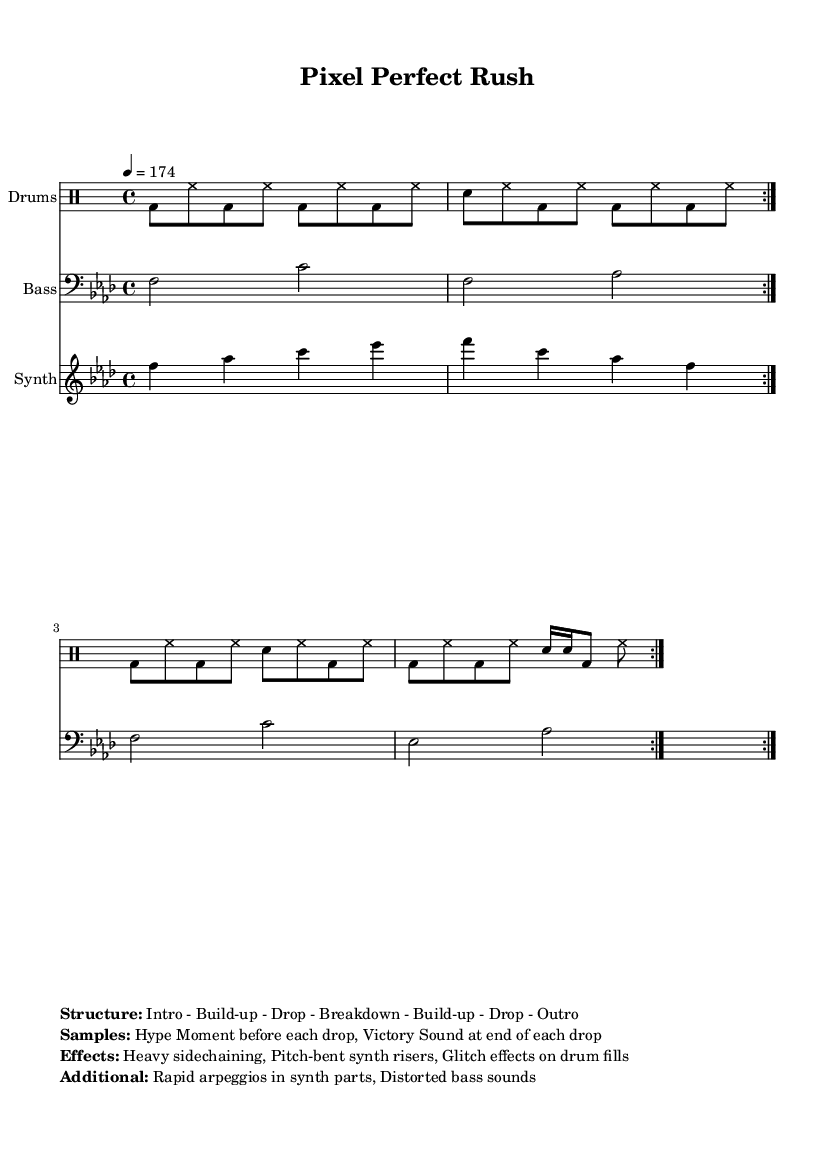What is the key signature of this music? The key signature is indicated as F minor, which has four flats.
Answer: F minor What is the time signature of this music? The time signature is given as 4/4, indicating four beats per measure.
Answer: 4/4 What is the tempo of the piece? The tempo marking is specified as 4 = 174, meaning there are 174 beats per minute.
Answer: 174 How many times is the bass part repeated? The score indicates the bass part is repeated twice, as shown by the "volta 2" instruction.
Answer: 2 What effect is used heavily in this track? The sheet music mentions heavy sidechaining as a prominent effect, which is common in this genre.
Answer: Heavy sidechaining What notable sample is used before each drop? The music lists "Hype Moment" as the sample played before each drop, helping to build excitement.
Answer: Hype Moment What kind of sound is included at the end of each drop? The score notes that the "Victory Sound" is used at the end of each drop, which adds to the celebratory feel.
Answer: Victory Sound 